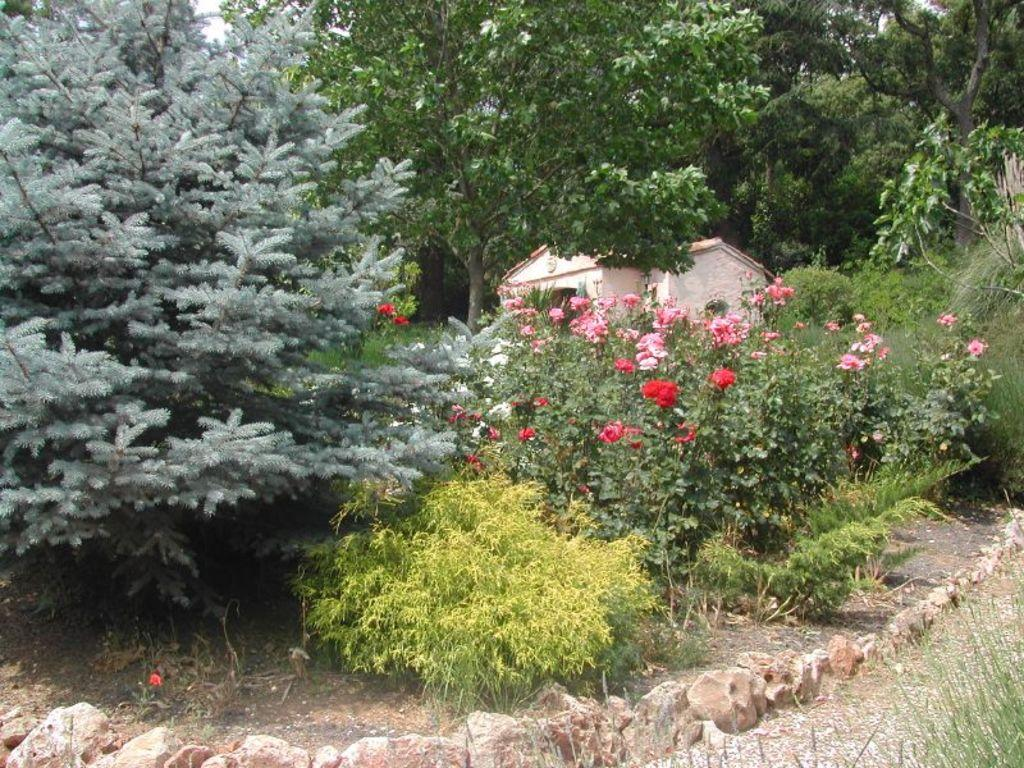What type of plants can be seen in the image? There are flowers, trees, and bushes in the image. What type of structure is present in the image? There is a house in the image. Where is the writer sitting in the image? There is no writer present in the image. What type of ice formations can be seen hanging from the trees in the image? There are no ice formations, such as icicles, present in the image. 